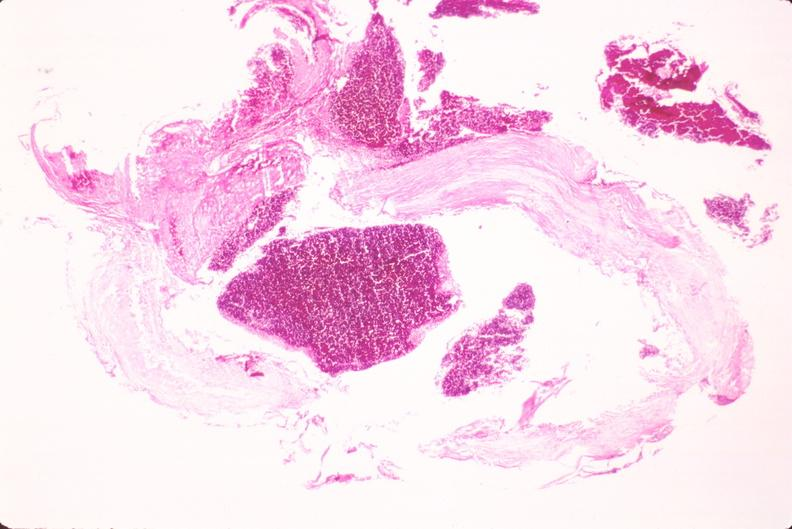s lateral view present?
Answer the question using a single word or phrase. No 